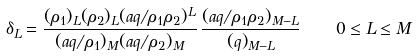Convert formula to latex. <formula><loc_0><loc_0><loc_500><loc_500>\delta _ { L } = \frac { ( \rho _ { 1 } ) _ { L } ( \rho _ { 2 } ) _ { L } ( a q / \rho _ { 1 } \rho _ { 2 } ) ^ { L } } { ( a q / \rho _ { 1 } ) _ { M } ( a q / \rho _ { 2 } ) _ { M } } \, \frac { ( a q / \rho _ { 1 } \rho _ { 2 } ) _ { M - L } } { ( q ) _ { M - L } } \quad 0 \leq L \leq M</formula> 